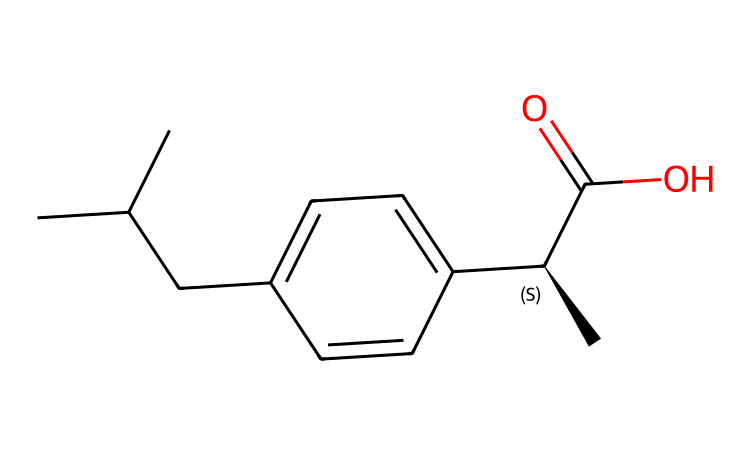What is the chemical name of the compound represented by the SMILES? The given SMILES corresponds to ibuprofen, which is a nonsteroidal anti-inflammatory drug (NSAID).
Answer: ibuprofen How many chiral centers are present in this compound? Analyzing the structure, there is one chiral center in ibuprofen, indicated by the "@H" in the SMILES representation.
Answer: one What functional groups are present in this compound? The compound contains a carboxylic acid group (C(=O)O) and an aromatic ring (the "c" characters in the SMILES). These are the primary functional groups present in ibuprofen.
Answer: carboxylic acid and aromatic ring How does chirality affect the efficacy of ibuprofen? The chiral form of ibuprofen, specifically the S-enantiomer, is more therapeutically active compared to the R-enantiomer. Different enantiomers can have distinct pharmacological effects and potencies.
Answer: S-enantiomer What is the primary pharmacological action of ibuprofen? Ibuprofen primarily functions as a nonsteroidal anti-inflammatory drug (NSAID), providing pain relief and reducing inflammation.
Answer: anti-inflammatory What is the total number of carbon atoms in the ibuprofen structure? By counting the carbon atoms directly from the SMILES and confirming the structure, there are 13 carbon atoms in the ibuprofen molecule.
Answer: thirteen What type of isomerism does ibuprofen exhibit? Ibuprofen exhibits stereoisomerism due to the presence of a chiral center, resulting in the occurrence of enantiomers (S and R forms).
Answer: stereoisomerism 